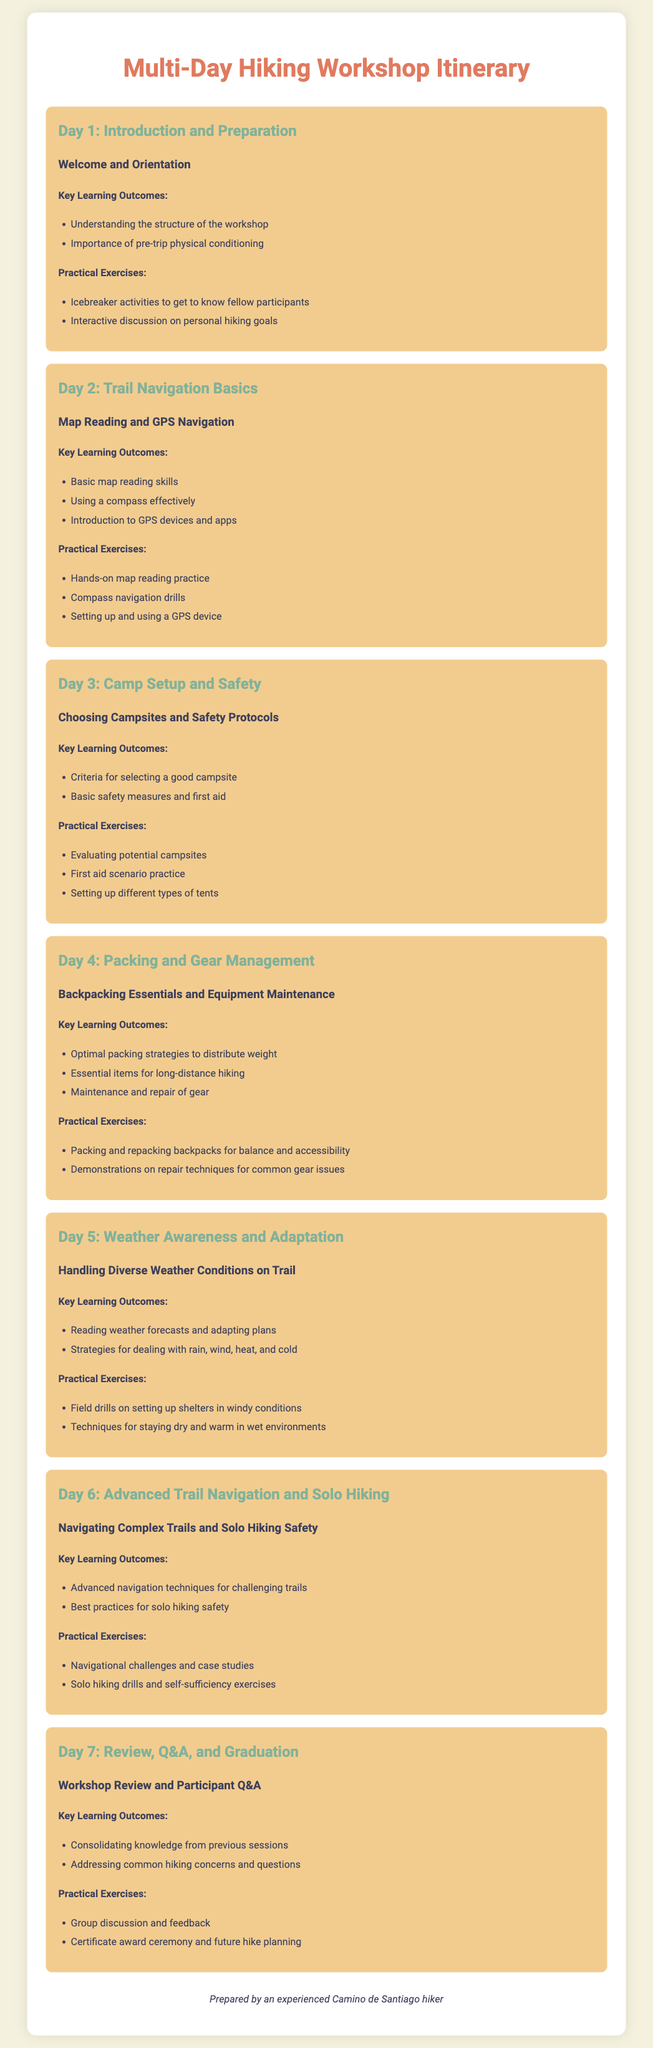What is the title of the document? The title is presented at the top of the document and describes the content, which is a schedule for a hiking workshop.
Answer: Multi-Day Hiking Workshop Itinerary How many days does the workshop last? The document lists activities for each day, indicating the total number of days the workshop spans.
Answer: 7 What is covered on Day 2? The content for each day includes specific themes, and Day 2 is focused on trail navigation.
Answer: Trail Navigation Basics Which day focuses on packing strategies? Each day has a specific focus, and packing strategies are highlighted on one particular day.
Answer: Day 4 Name one practical exercise from Day 3. The practical exercises section lists activities for each day, including specific hands-on exercises for that day.
Answer: Evaluating potential campsites What key learning outcome is addressed on Day 5? Each day outlines key learning outcomes, and Day 5 includes the ability to read weather forecasts.
Answer: Reading weather forecasts and adapting plans How many practical exercises are included in Day 6? By counting the practical exercises listed for Day 6 in the document, we find the total number of exercises for that day.
Answer: 2 What key learning outcomes are reviewed on the last day? The final day summarizes the knowledge acquired during the workshop, listing outcomes for review.
Answer: Consolidating knowledge from previous sessions 